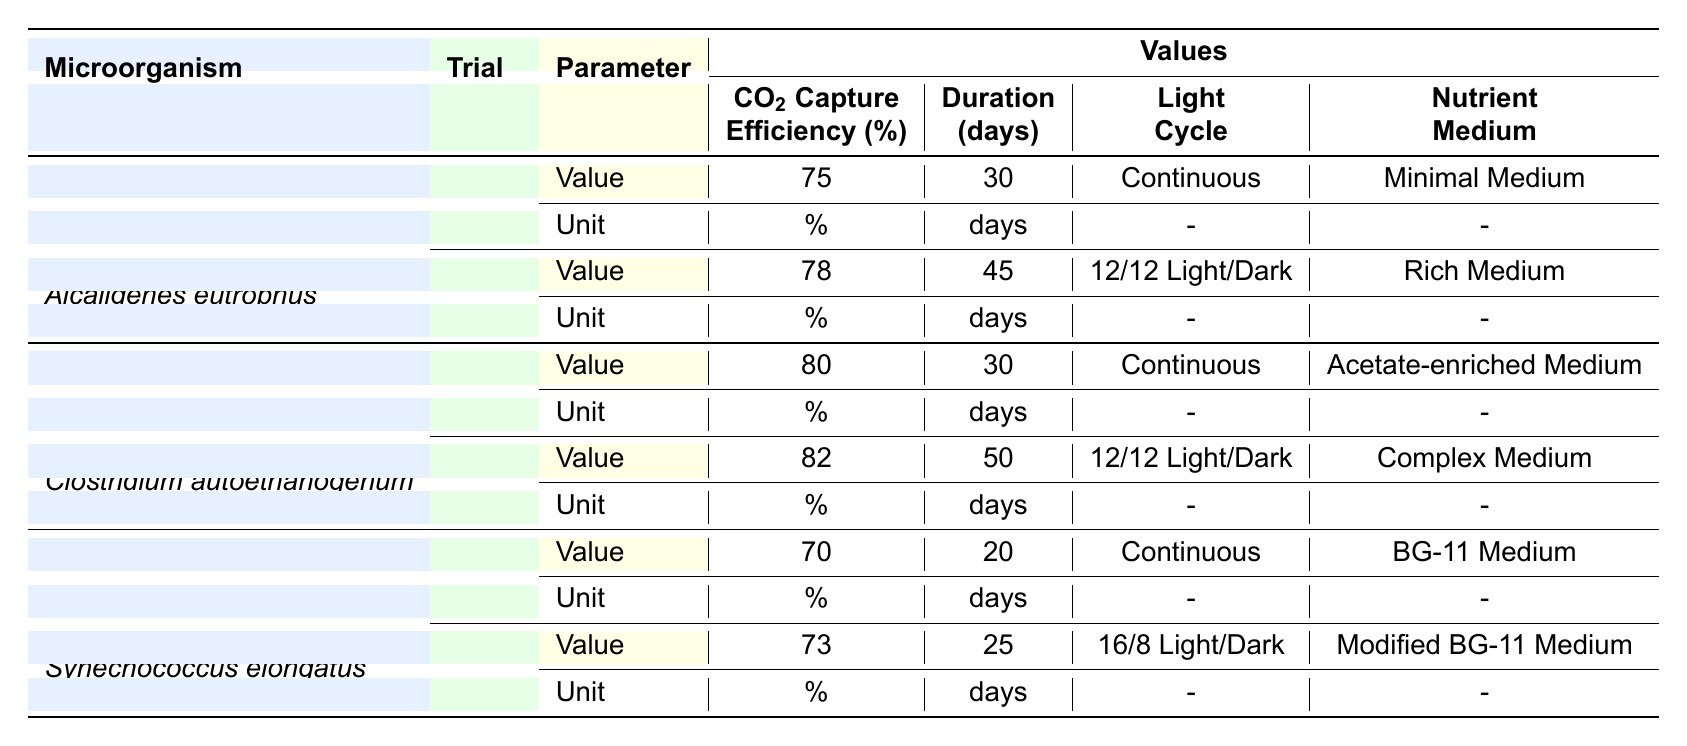What is the CO2 capture efficiency for Alcaligenes eutrophus in Trial 1? The table lists the CO2 capture efficiency for Alcaligenes eutrophus in Trial 1 as 75%.
Answer: 75% What is the nutrient medium used in Trial 2 of Clostridium autoethanogenum? According to the table, the nutrient medium used in Trial 2 of Clostridium autoethanogenum is Complex Medium.
Answer: Complex Medium Which microorganism had the highest CO2 capture efficiency? By comparing the CO2 capture efficiencies: Alcaligenes eutrophus (78%), Clostridium autoethanogenum (82%), and Synechococcus elongatus (73%), Clostridium autoethanogenum has the highest efficiency at 82%.
Answer: Clostridium autoethanogenum What is the average duration of the trials for Synechococcus elongatus? The durations for Synechococcus elongatus are 20 days (Trial 1) and 25 days (Trial 2). The average is calculated as (20 + 25) / 2 = 22.5 days.
Answer: 22.5 days Is the light cycle for Trial 1 of Alcaligenes eutrophus continuous? The table indicates that the light cycle for Trial 1 of Alcaligenes eutrophus is Continuous.
Answer: Yes What is the difference in CO2 capture efficiency between Trial 1 and Trial 2 for Clostridium autoethanogenum? The CO2 capture efficiencies for Clostridium autoethanogenum are 80% (Trial 1) and 82% (Trial 2). The difference is calculated as 82 - 80 = 2%.
Answer: 2% Which microorganism had a CO2 capture efficiency greater than 75% in both trials? Upon analyzing the data: Clostridium autoethanogenum had efficiencies of 80% and 82%, while Alcaligenes eutrophus had 75% and 78%, and Synechococcus elongatus had 70% and 73%. Only Clostridium autoethanogenum had both values greater than 75%.
Answer: Clostridium autoethanogenum How many total days were the microorganisms tested across all trials? The total duration of the trials is the sum of days: Alcaligenes eutrophus (30 + 45), Clostridium autoethanogenum (30 + 50), and Synechococcus elongatus (20 + 25). This totals 30 + 45 + 30 + 50 + 20 + 25 = 200 days.
Answer: 200 days 